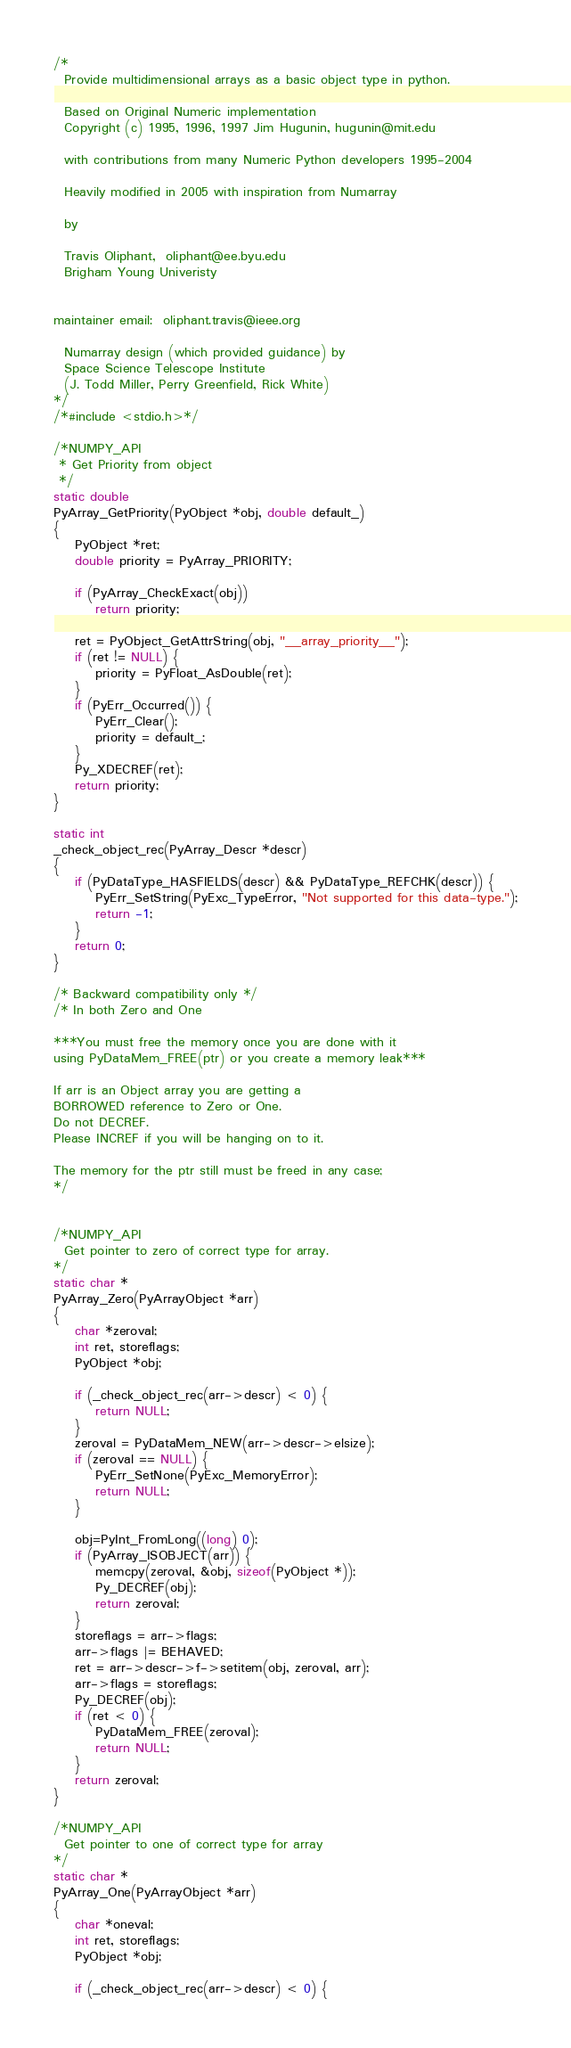Convert code to text. <code><loc_0><loc_0><loc_500><loc_500><_C_>/*
  Provide multidimensional arrays as a basic object type in python.

  Based on Original Numeric implementation
  Copyright (c) 1995, 1996, 1997 Jim Hugunin, hugunin@mit.edu

  with contributions from many Numeric Python developers 1995-2004

  Heavily modified in 2005 with inspiration from Numarray

  by

  Travis Oliphant,  oliphant@ee.byu.edu
  Brigham Young Univeristy


maintainer email:  oliphant.travis@ieee.org

  Numarray design (which provided guidance) by
  Space Science Telescope Institute
  (J. Todd Miller, Perry Greenfield, Rick White)
*/
/*#include <stdio.h>*/

/*NUMPY_API
 * Get Priority from object
 */
static double
PyArray_GetPriority(PyObject *obj, double default_)
{
    PyObject *ret;
    double priority = PyArray_PRIORITY;

    if (PyArray_CheckExact(obj))
        return priority;

    ret = PyObject_GetAttrString(obj, "__array_priority__");
    if (ret != NULL) {
        priority = PyFloat_AsDouble(ret);
    }
    if (PyErr_Occurred()) {
        PyErr_Clear();
        priority = default_;
    }
    Py_XDECREF(ret);
    return priority;
}

static int
_check_object_rec(PyArray_Descr *descr)
{
    if (PyDataType_HASFIELDS(descr) && PyDataType_REFCHK(descr)) {
        PyErr_SetString(PyExc_TypeError, "Not supported for this data-type.");
        return -1;
    }
    return 0;
}

/* Backward compatibility only */
/* In both Zero and One

***You must free the memory once you are done with it
using PyDataMem_FREE(ptr) or you create a memory leak***

If arr is an Object array you are getting a
BORROWED reference to Zero or One.
Do not DECREF.
Please INCREF if you will be hanging on to it.

The memory for the ptr still must be freed in any case;
*/


/*NUMPY_API
  Get pointer to zero of correct type for array.
*/
static char *
PyArray_Zero(PyArrayObject *arr)
{
    char *zeroval;
    int ret, storeflags;
    PyObject *obj;

    if (_check_object_rec(arr->descr) < 0) {
        return NULL;
    }
    zeroval = PyDataMem_NEW(arr->descr->elsize);
    if (zeroval == NULL) {
        PyErr_SetNone(PyExc_MemoryError);
        return NULL;
    }

    obj=PyInt_FromLong((long) 0);
    if (PyArray_ISOBJECT(arr)) {
        memcpy(zeroval, &obj, sizeof(PyObject *));
        Py_DECREF(obj);
        return zeroval;
    }
    storeflags = arr->flags;
    arr->flags |= BEHAVED;
    ret = arr->descr->f->setitem(obj, zeroval, arr);
    arr->flags = storeflags;
    Py_DECREF(obj);
    if (ret < 0) {
        PyDataMem_FREE(zeroval);
        return NULL;
    }
    return zeroval;
}

/*NUMPY_API
  Get pointer to one of correct type for array
*/
static char *
PyArray_One(PyArrayObject *arr)
{
    char *oneval;
    int ret, storeflags;
    PyObject *obj;

    if (_check_object_rec(arr->descr) < 0) {</code> 